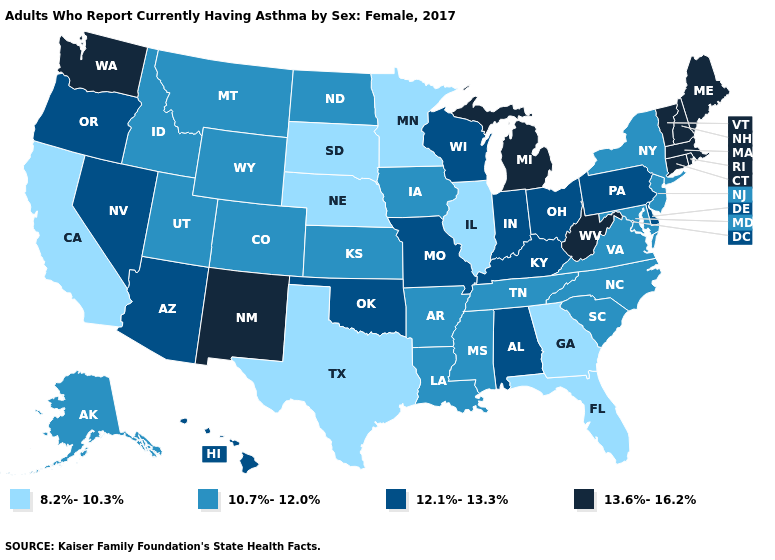Does Florida have the highest value in the South?
Write a very short answer. No. What is the value of Mississippi?
Give a very brief answer. 10.7%-12.0%. What is the highest value in states that border Pennsylvania?
Keep it brief. 13.6%-16.2%. What is the highest value in the MidWest ?
Keep it brief. 13.6%-16.2%. Does Indiana have the same value as Oregon?
Keep it brief. Yes. What is the lowest value in the USA?
Be succinct. 8.2%-10.3%. Name the states that have a value in the range 12.1%-13.3%?
Short answer required. Alabama, Arizona, Delaware, Hawaii, Indiana, Kentucky, Missouri, Nevada, Ohio, Oklahoma, Oregon, Pennsylvania, Wisconsin. Name the states that have a value in the range 8.2%-10.3%?
Be succinct. California, Florida, Georgia, Illinois, Minnesota, Nebraska, South Dakota, Texas. Name the states that have a value in the range 12.1%-13.3%?
Be succinct. Alabama, Arizona, Delaware, Hawaii, Indiana, Kentucky, Missouri, Nevada, Ohio, Oklahoma, Oregon, Pennsylvania, Wisconsin. Which states have the lowest value in the MidWest?
Answer briefly. Illinois, Minnesota, Nebraska, South Dakota. Which states have the lowest value in the South?
Write a very short answer. Florida, Georgia, Texas. Does the first symbol in the legend represent the smallest category?
Quick response, please. Yes. Name the states that have a value in the range 10.7%-12.0%?
Be succinct. Alaska, Arkansas, Colorado, Idaho, Iowa, Kansas, Louisiana, Maryland, Mississippi, Montana, New Jersey, New York, North Carolina, North Dakota, South Carolina, Tennessee, Utah, Virginia, Wyoming. Does Oklahoma have the lowest value in the South?
Write a very short answer. No. Name the states that have a value in the range 12.1%-13.3%?
Keep it brief. Alabama, Arizona, Delaware, Hawaii, Indiana, Kentucky, Missouri, Nevada, Ohio, Oklahoma, Oregon, Pennsylvania, Wisconsin. 